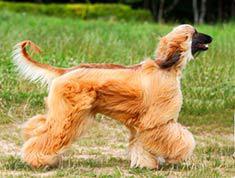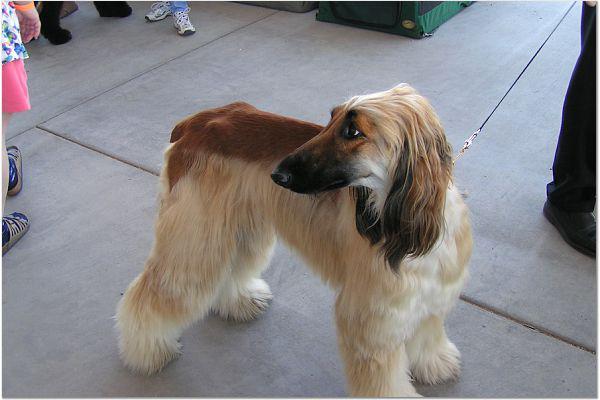The first image is the image on the left, the second image is the image on the right. Considering the images on both sides, is "One photo contains exactly two dogs while the other photo contains only one, and all dogs are photographed outside in grass." valid? Answer yes or no. No. The first image is the image on the left, the second image is the image on the right. Examine the images to the left and right. Is the description "There are exactly three dogs in total." accurate? Answer yes or no. No. 